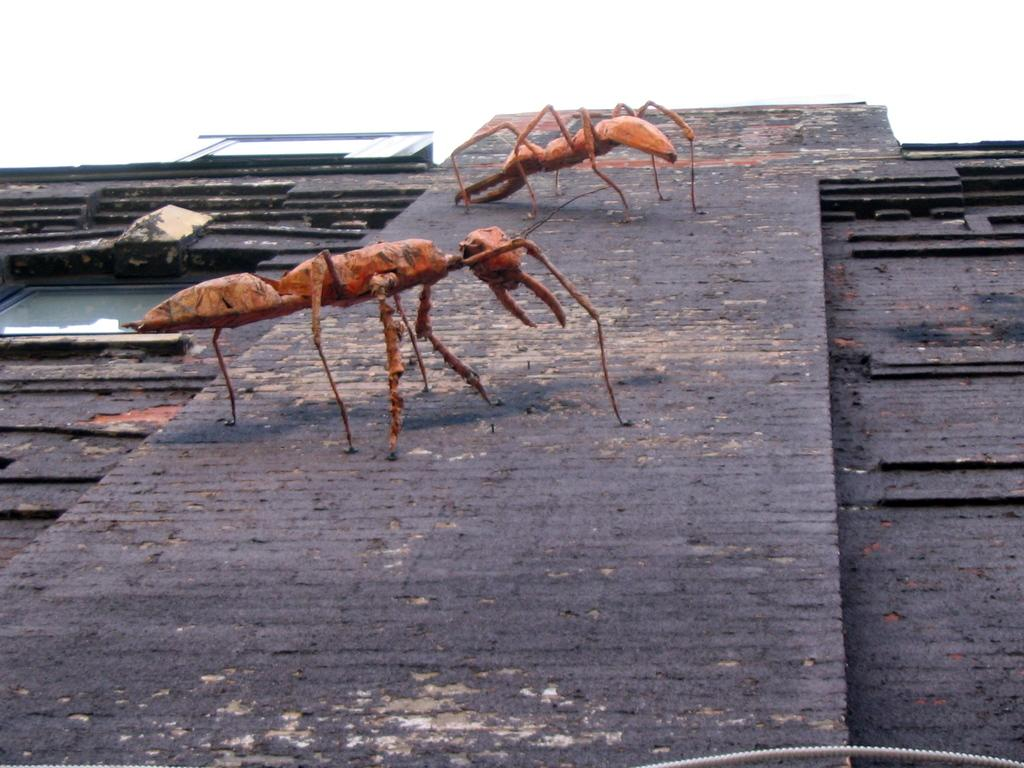How many ants are present in the image? There are two ants in the image. What color are the ants? The ants are red in color. What surface are the ants on? The ants are on a brown surface. What can be seen in the background of the image? There is a sky visible in the background of the image. What type of sticks are the ants using to build a structure in the image? There are no sticks present in the image, and the ants are not building any structures. 